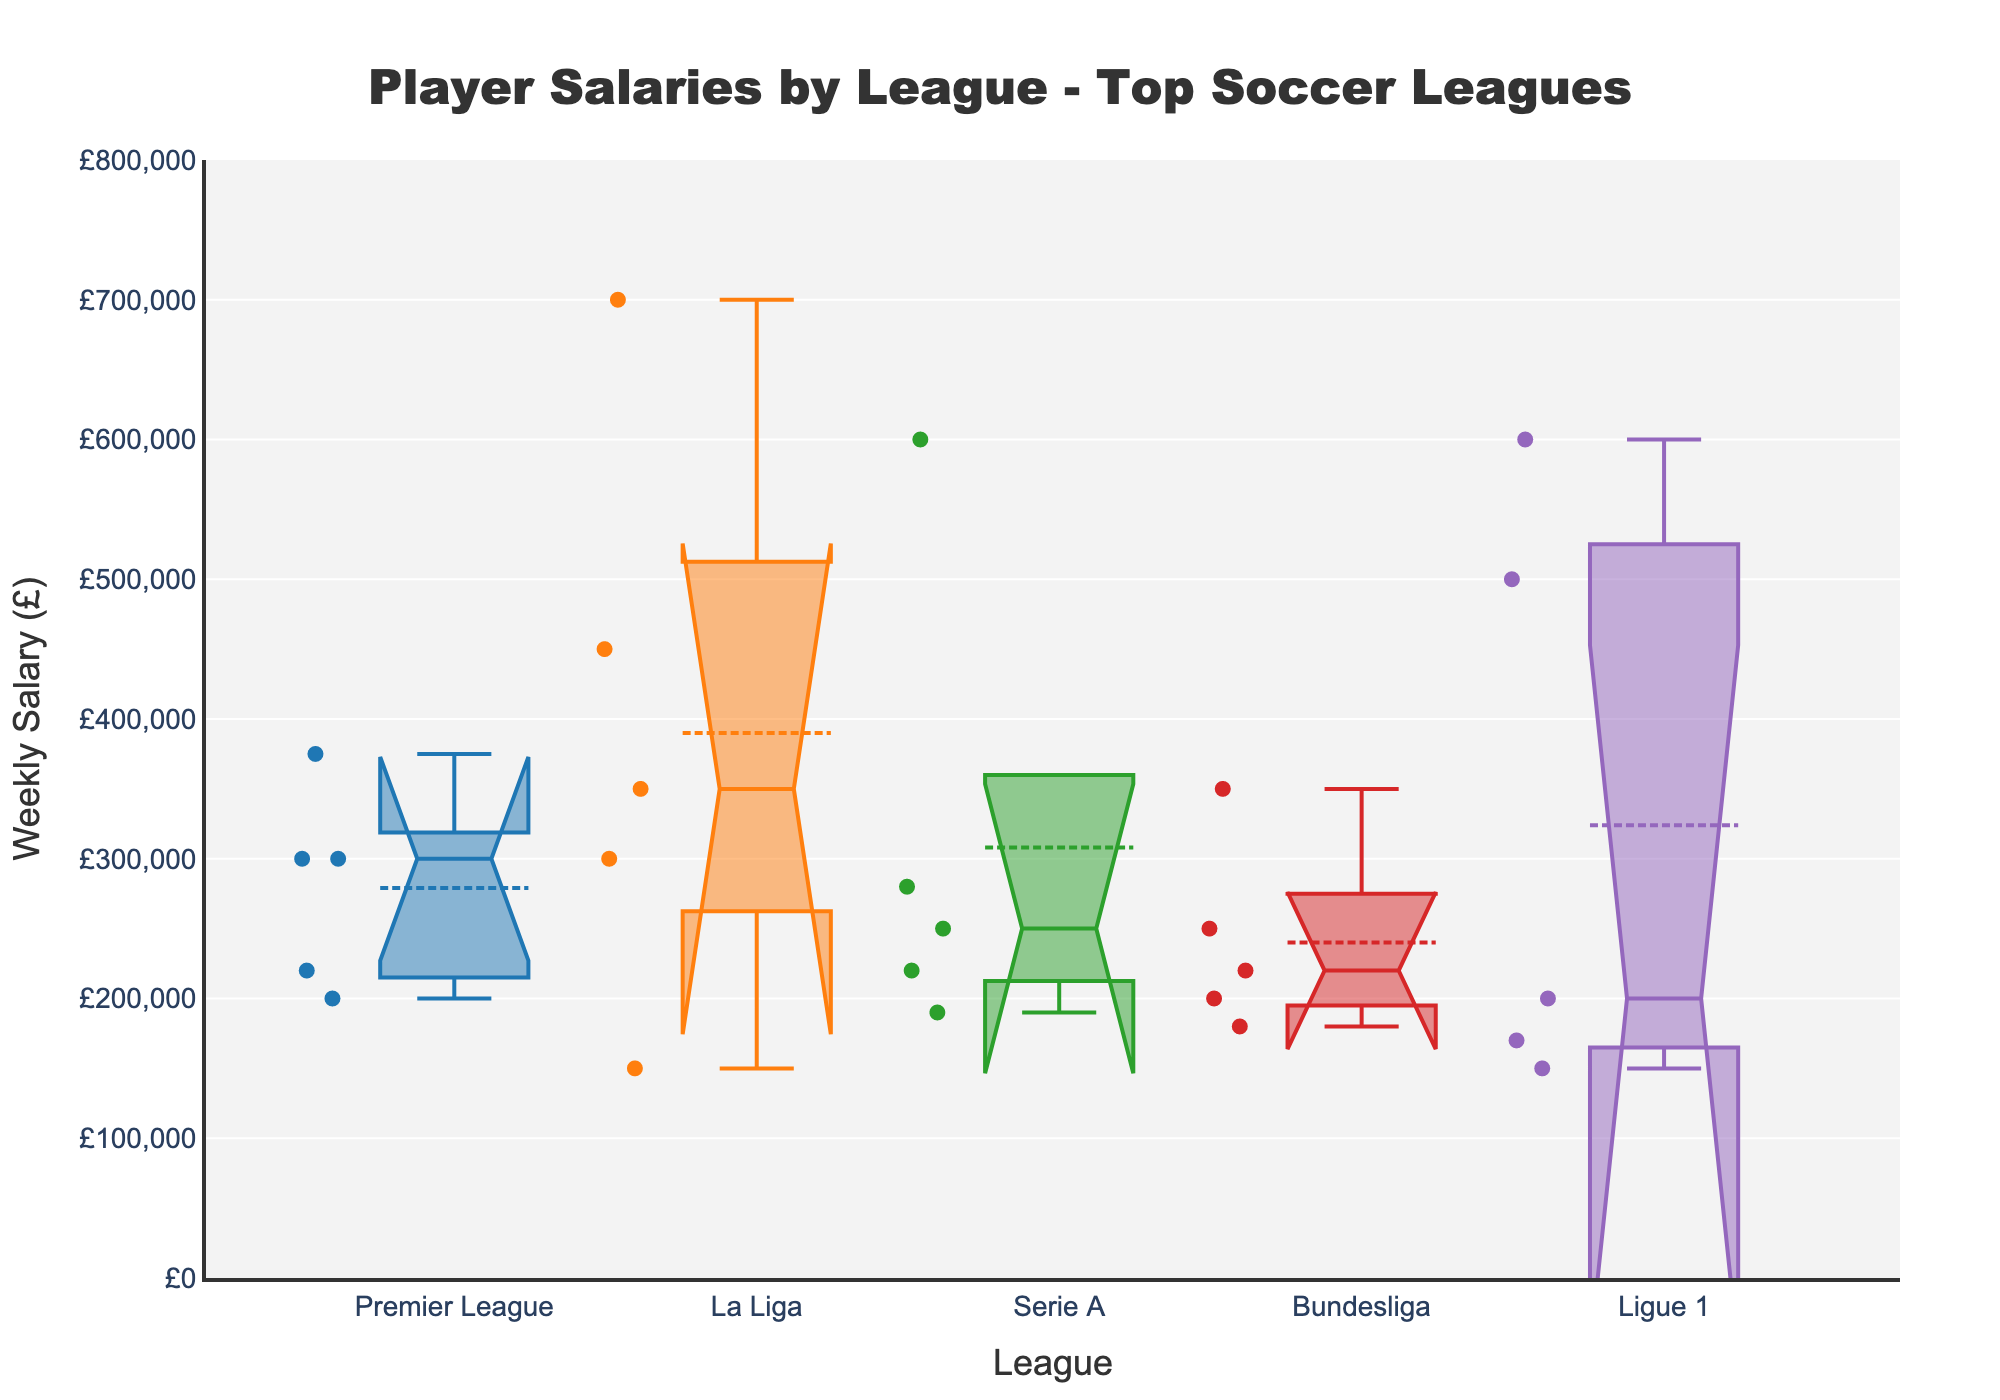What is the title of the plot? Look at the top of the visual where the title is normally placed. The title is a textual representation providing an overview of the content in the plot.
Answer: Player Salaries by League - Top Soccer Leagues What is the range of the y-axis in the plot? Examine the y-axis on the left side of the plot to determine the minimum and maximum values that it covers.
Answer: 0 to 800000 What does the y-axis represent in this plot? Observe the label next to the y-axis, which indicates what the variable on this axis measures.
Answer: Weekly Salary (£) Which league has the highest median salary? Identify the median line (usually the line within the box) for each league and compare which is highest.
Answer: La Liga Which league appears to have the widest range of salaries? Compare the length of the boxes and the whiskers extending from each box to see which league spans the most significant interval on the y-axis.
Answer: La Liga How do Premier League and Bundesliga compare in terms of player salary medians? Look at the median lines in the boxes for Premier League and Bundesliga to compare their positions on the y-axis.
Answer: Premier League has a higher median salary than Bundesliga What is the approximate interquartile range (IQR) of Ligue 1 salaries? To find the IQR, look at the length of the box for Ligue 1 as it represents the range from the first quartile (Q1) to the third quartile (Q3). Estimate these positions on the y-axis.
Answer: Approximately 150,000 - 600,000 = 450,000 Which league has the narrowest notch in the box plot, and what does this imply? Identify the notch's width in each league's box indicating the confidence interval for the median. The narrowest notch suggests a more precise estimation of the median.
Answer: Bundesliga; more precise median Between Serie A and Ligue 1, which league has more variability in player salaries? Examine the length and spread of the boxes and whiskers for Serie A and Ligue 1 to compare their variability.
Answer: Ligue 1 Does La Liga or Premier League have more variability in player salaries? Look at the length and spread of the boxes and whiskers for both leagues and compare which one has a broader span.
Answer: La Liga 